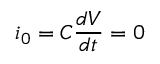Convert formula to latex. <formula><loc_0><loc_0><loc_500><loc_500>i _ { 0 } = C \frac { d V } { d t } = 0</formula> 